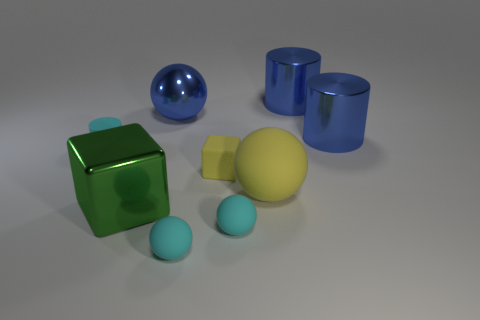How many things are either small cyan rubber things or large spheres to the right of the tiny cube?
Your answer should be compact. 4. What material is the blue thing that is the same shape as the large yellow rubber thing?
Offer a terse response. Metal. There is a thing that is both on the right side of the cyan rubber cylinder and on the left side of the shiny sphere; what material is it?
Provide a succinct answer. Metal. What number of cyan things are the same shape as the green metallic object?
Offer a very short reply. 0. There is a tiny thing that is left of the metallic object that is in front of the large matte sphere; what color is it?
Give a very brief answer. Cyan. Are there an equal number of cyan rubber cylinders that are in front of the large green metal thing and small cyan metal cylinders?
Provide a short and direct response. Yes. Are there any blue cylinders of the same size as the green shiny thing?
Your answer should be very brief. Yes. Does the yellow cube have the same size as the rubber object that is left of the metallic cube?
Offer a terse response. Yes. Is the number of big blue things that are to the left of the green metal object the same as the number of blue shiny objects behind the tiny rubber cylinder?
Give a very brief answer. No. What shape is the big rubber thing that is the same color as the matte cube?
Your answer should be very brief. Sphere. 